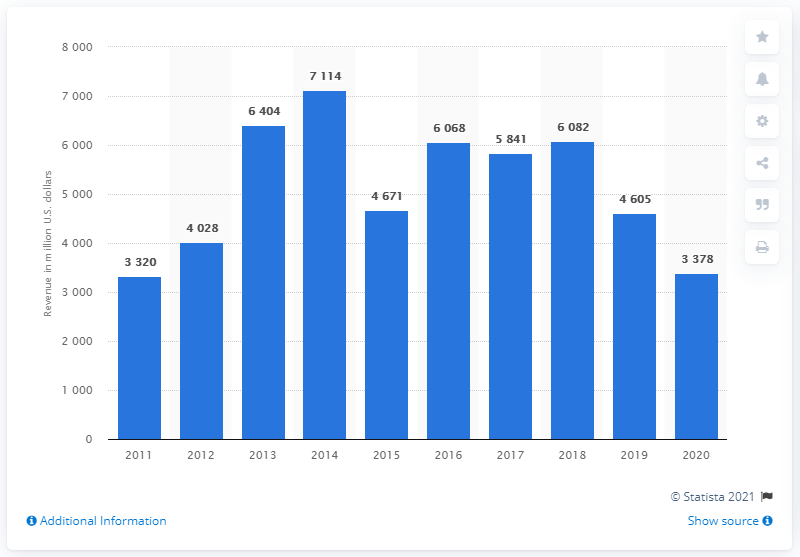Specify some key components in this picture. In 2020, the revenue of De Beers was 3,378 million dollars. 